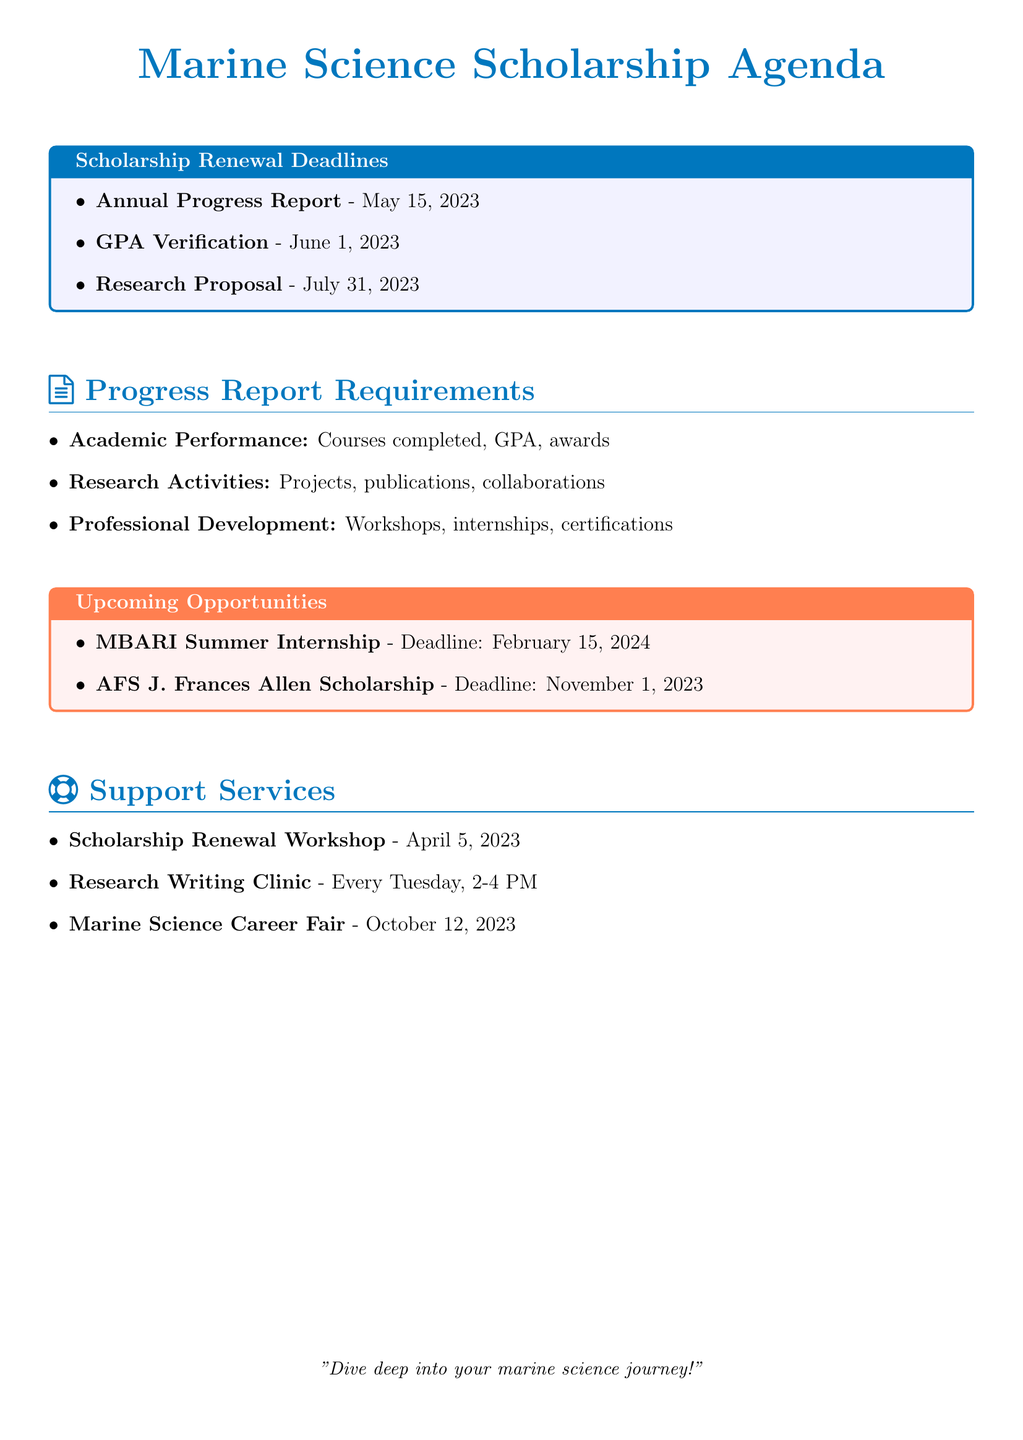What is the deadline for the Annual Progress Report? The deadline is described in the scholarship renewal deadlines section of the document.
Answer: May 15, 2023 What is required for GPA Verification? The requirement is mentioned under the scholarship renewal deadlines section.
Answer: Official transcripts What is the deadline for the Research Proposal for Next Academic Year? This information is found in the scholarship renewal deadlines section.
Answer: July 31, 2023 What category includes "List of publications or conference presentations"? This item is found under the research activities category in the progress report requirements.
Answer: Research Activities What is the date of the Scholarship Renewal Workshop? This date is specified in the support services section.
Answer: April 5, 2023 Which opportunity has a deadline in February 2024? The upcoming scholarship opportunities section provides this information.
Answer: MBARI Summer Internship What is the location for the Marine Science Career Fair? This detail is included in the support services section of the document.
Answer: University Conference Center How often does the Research Writing Clinic occur? The frequency is stated in the support services section.
Answer: Every Tuesday What is the required GPA for the NOAA Hollings Scholarship? This information can be inferred from the GPA verification requirement in the scholarship renewal deadlines.
Answer: 3.5 